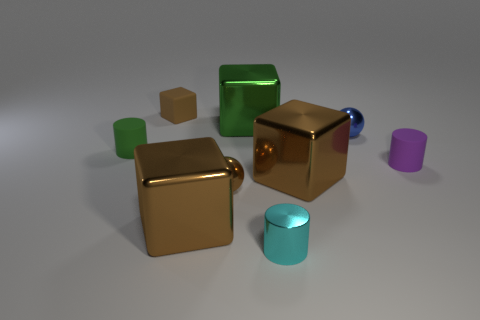What number of other metallic cubes are the same color as the tiny block?
Ensure brevity in your answer.  2. Is there a cyan object right of the rubber thing that is on the right side of the brown block that is in front of the brown ball?
Your response must be concise. No. What number of big green blocks are made of the same material as the small purple cylinder?
Your answer should be very brief. 0. There is a green object on the left side of the small brown cube; is its size the same as the brown object that is behind the tiny purple cylinder?
Provide a succinct answer. Yes. What is the color of the tiny metal sphere that is in front of the tiny cylinder that is to the right of the metal ball that is to the right of the tiny brown metal object?
Offer a very short reply. Brown. Is there a brown matte object that has the same shape as the purple matte object?
Provide a succinct answer. No. Is the number of purple cylinders behind the green shiny thing the same as the number of big brown metallic blocks right of the tiny cyan metallic thing?
Make the answer very short. No. There is a small brown object behind the purple object; is its shape the same as the large green metallic object?
Your response must be concise. Yes. Do the tiny cyan thing and the green matte object have the same shape?
Your answer should be very brief. Yes. What number of metal things are cubes or big green blocks?
Offer a terse response. 3. 